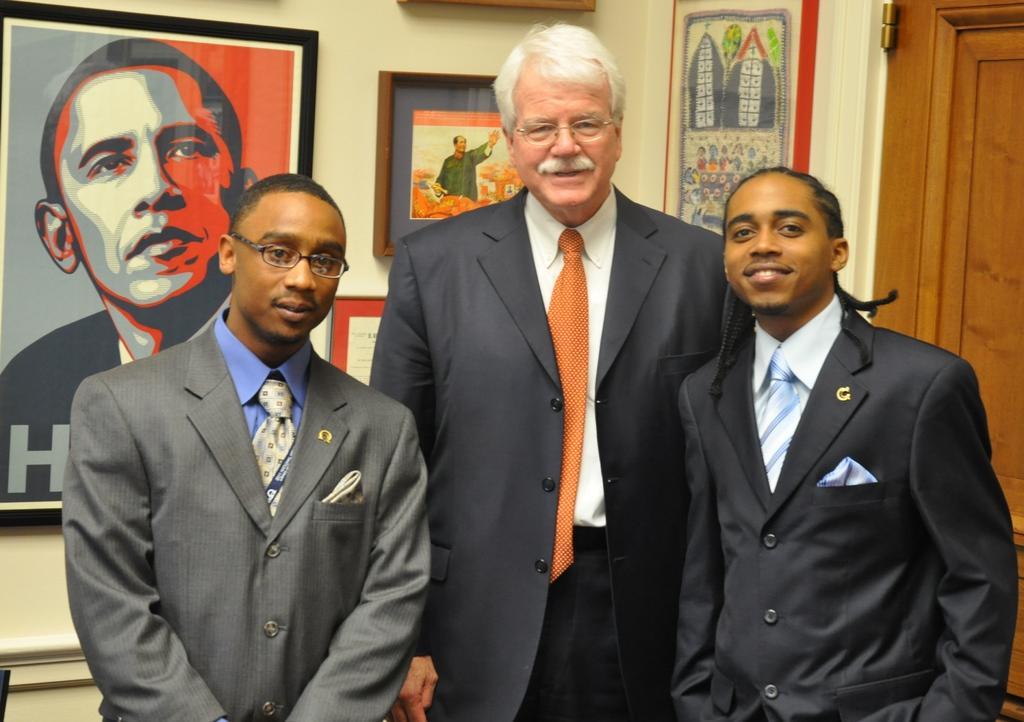In one or two sentences, can you explain what this image depicts? In this image we can see a group of people standing. On the backside we can see a door and some photo frames on a wall. 